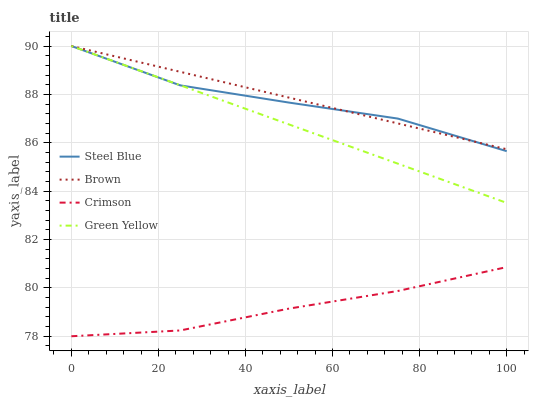Does Green Yellow have the minimum area under the curve?
Answer yes or no. No. Does Green Yellow have the maximum area under the curve?
Answer yes or no. No. Is Brown the smoothest?
Answer yes or no. No. Is Brown the roughest?
Answer yes or no. No. Does Green Yellow have the lowest value?
Answer yes or no. No. Is Crimson less than Brown?
Answer yes or no. Yes. Is Steel Blue greater than Crimson?
Answer yes or no. Yes. Does Crimson intersect Brown?
Answer yes or no. No. 